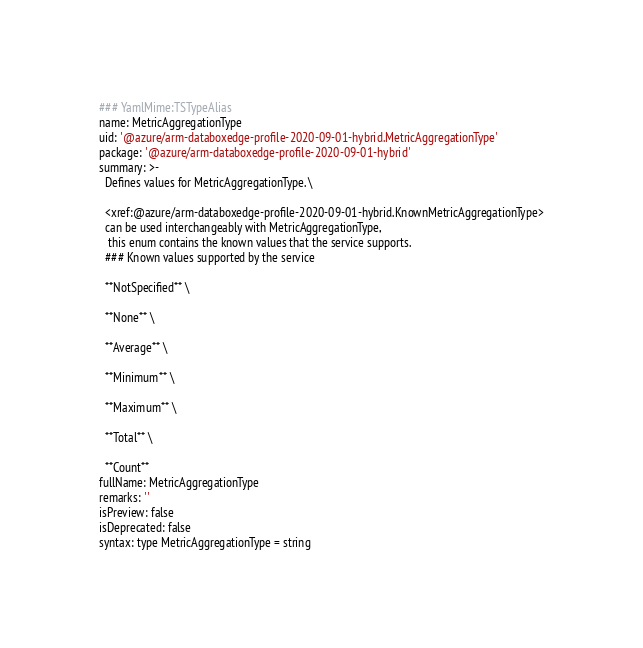Convert code to text. <code><loc_0><loc_0><loc_500><loc_500><_YAML_>### YamlMime:TSTypeAlias
name: MetricAggregationType
uid: '@azure/arm-databoxedge-profile-2020-09-01-hybrid.MetricAggregationType'
package: '@azure/arm-databoxedge-profile-2020-09-01-hybrid'
summary: >-
  Defines values for MetricAggregationType. \

  <xref:@azure/arm-databoxedge-profile-2020-09-01-hybrid.KnownMetricAggregationType>
  can be used interchangeably with MetricAggregationType,
   this enum contains the known values that the service supports.
  ### Known values supported by the service

  **NotSpecified** \

  **None** \

  **Average** \

  **Minimum** \

  **Maximum** \

  **Total** \

  **Count**
fullName: MetricAggregationType
remarks: ''
isPreview: false
isDeprecated: false
syntax: type MetricAggregationType = string
</code> 